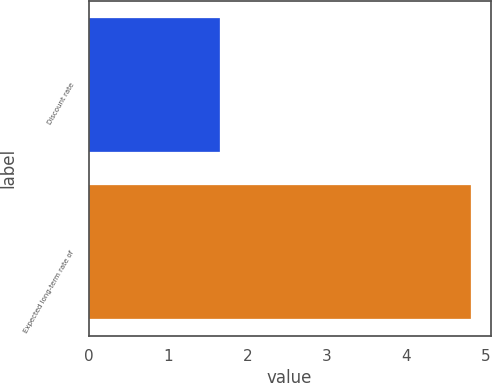<chart> <loc_0><loc_0><loc_500><loc_500><bar_chart><fcel>Discount rate<fcel>Expected long-term rate of<nl><fcel>1.65<fcel>4.82<nl></chart> 